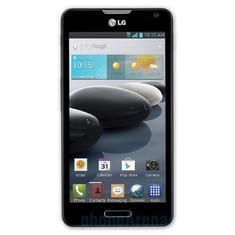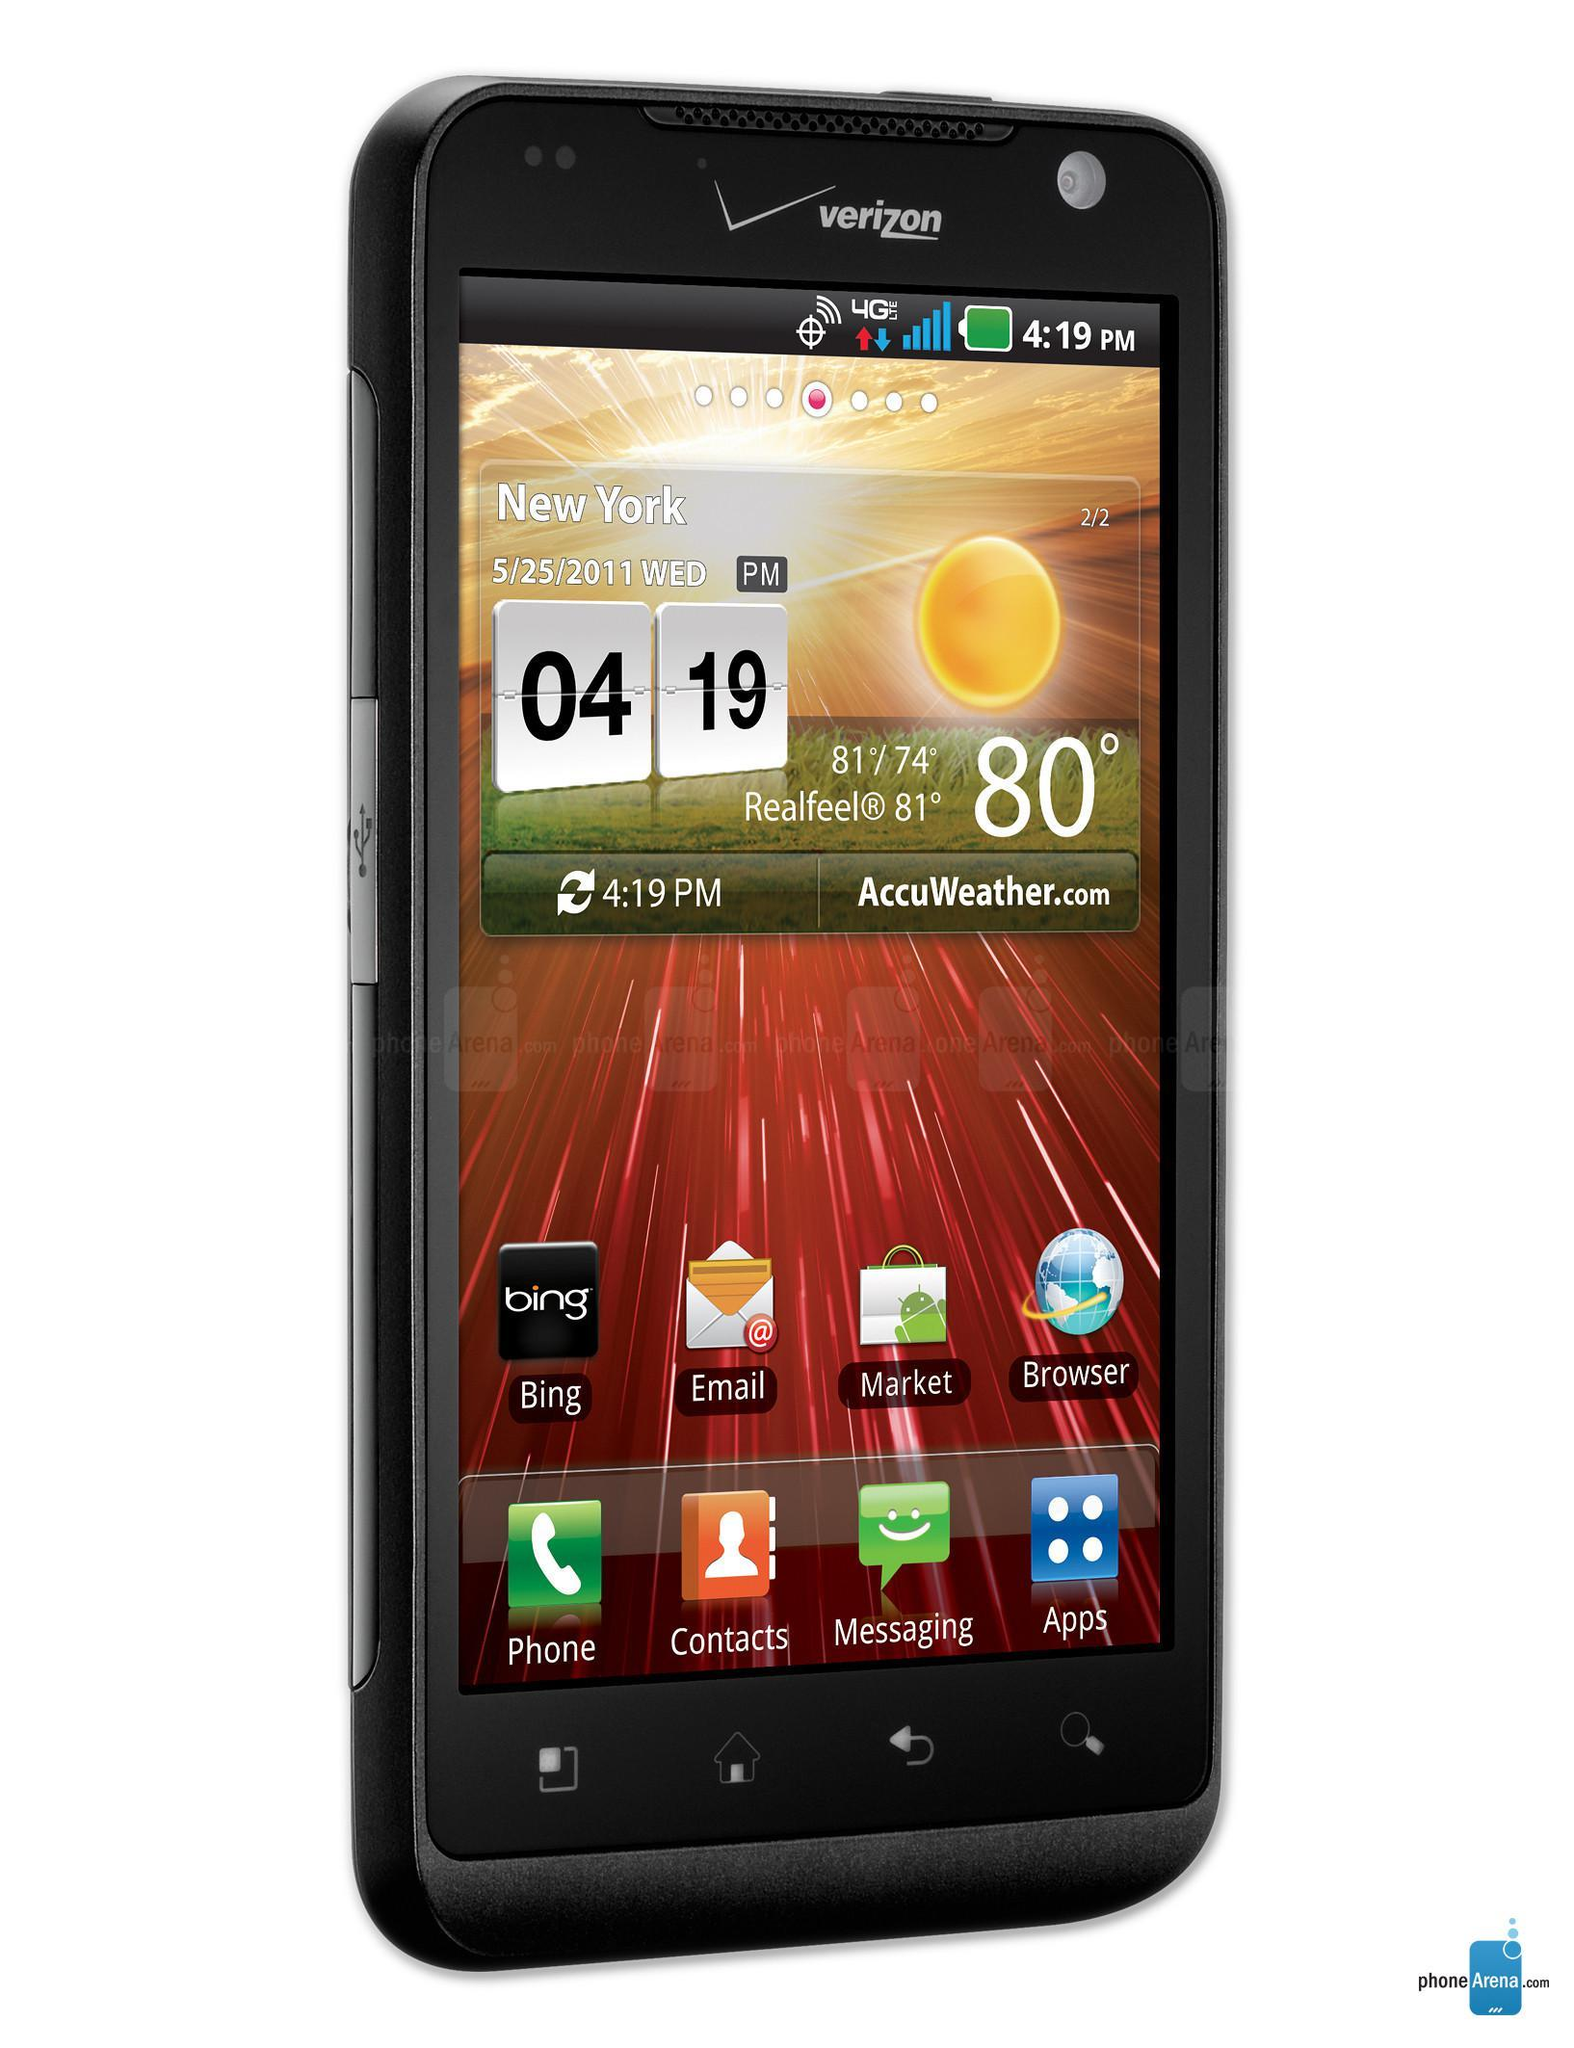The first image is the image on the left, the second image is the image on the right. Considering the images on both sides, is "One image shows a rectangular gray phone with a gray screen, and the other image shows a hand holding a phone." valid? Answer yes or no. No. The first image is the image on the left, the second image is the image on the right. For the images shown, is this caption "Only one hand is visible." true? Answer yes or no. No. 